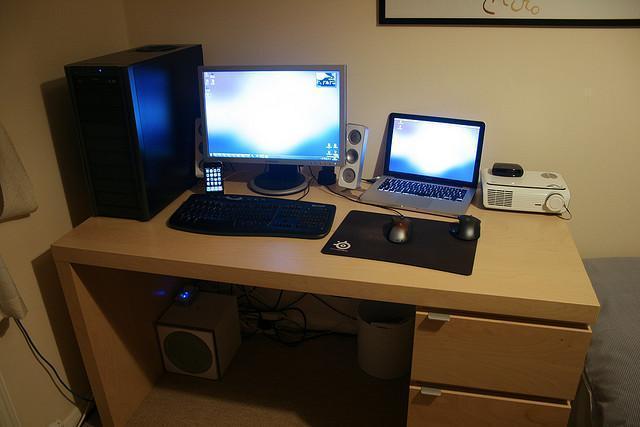How many lights are lit on the desktop CPU?
Give a very brief answer. 1. How many mice do you see?
Give a very brief answer. 2. 